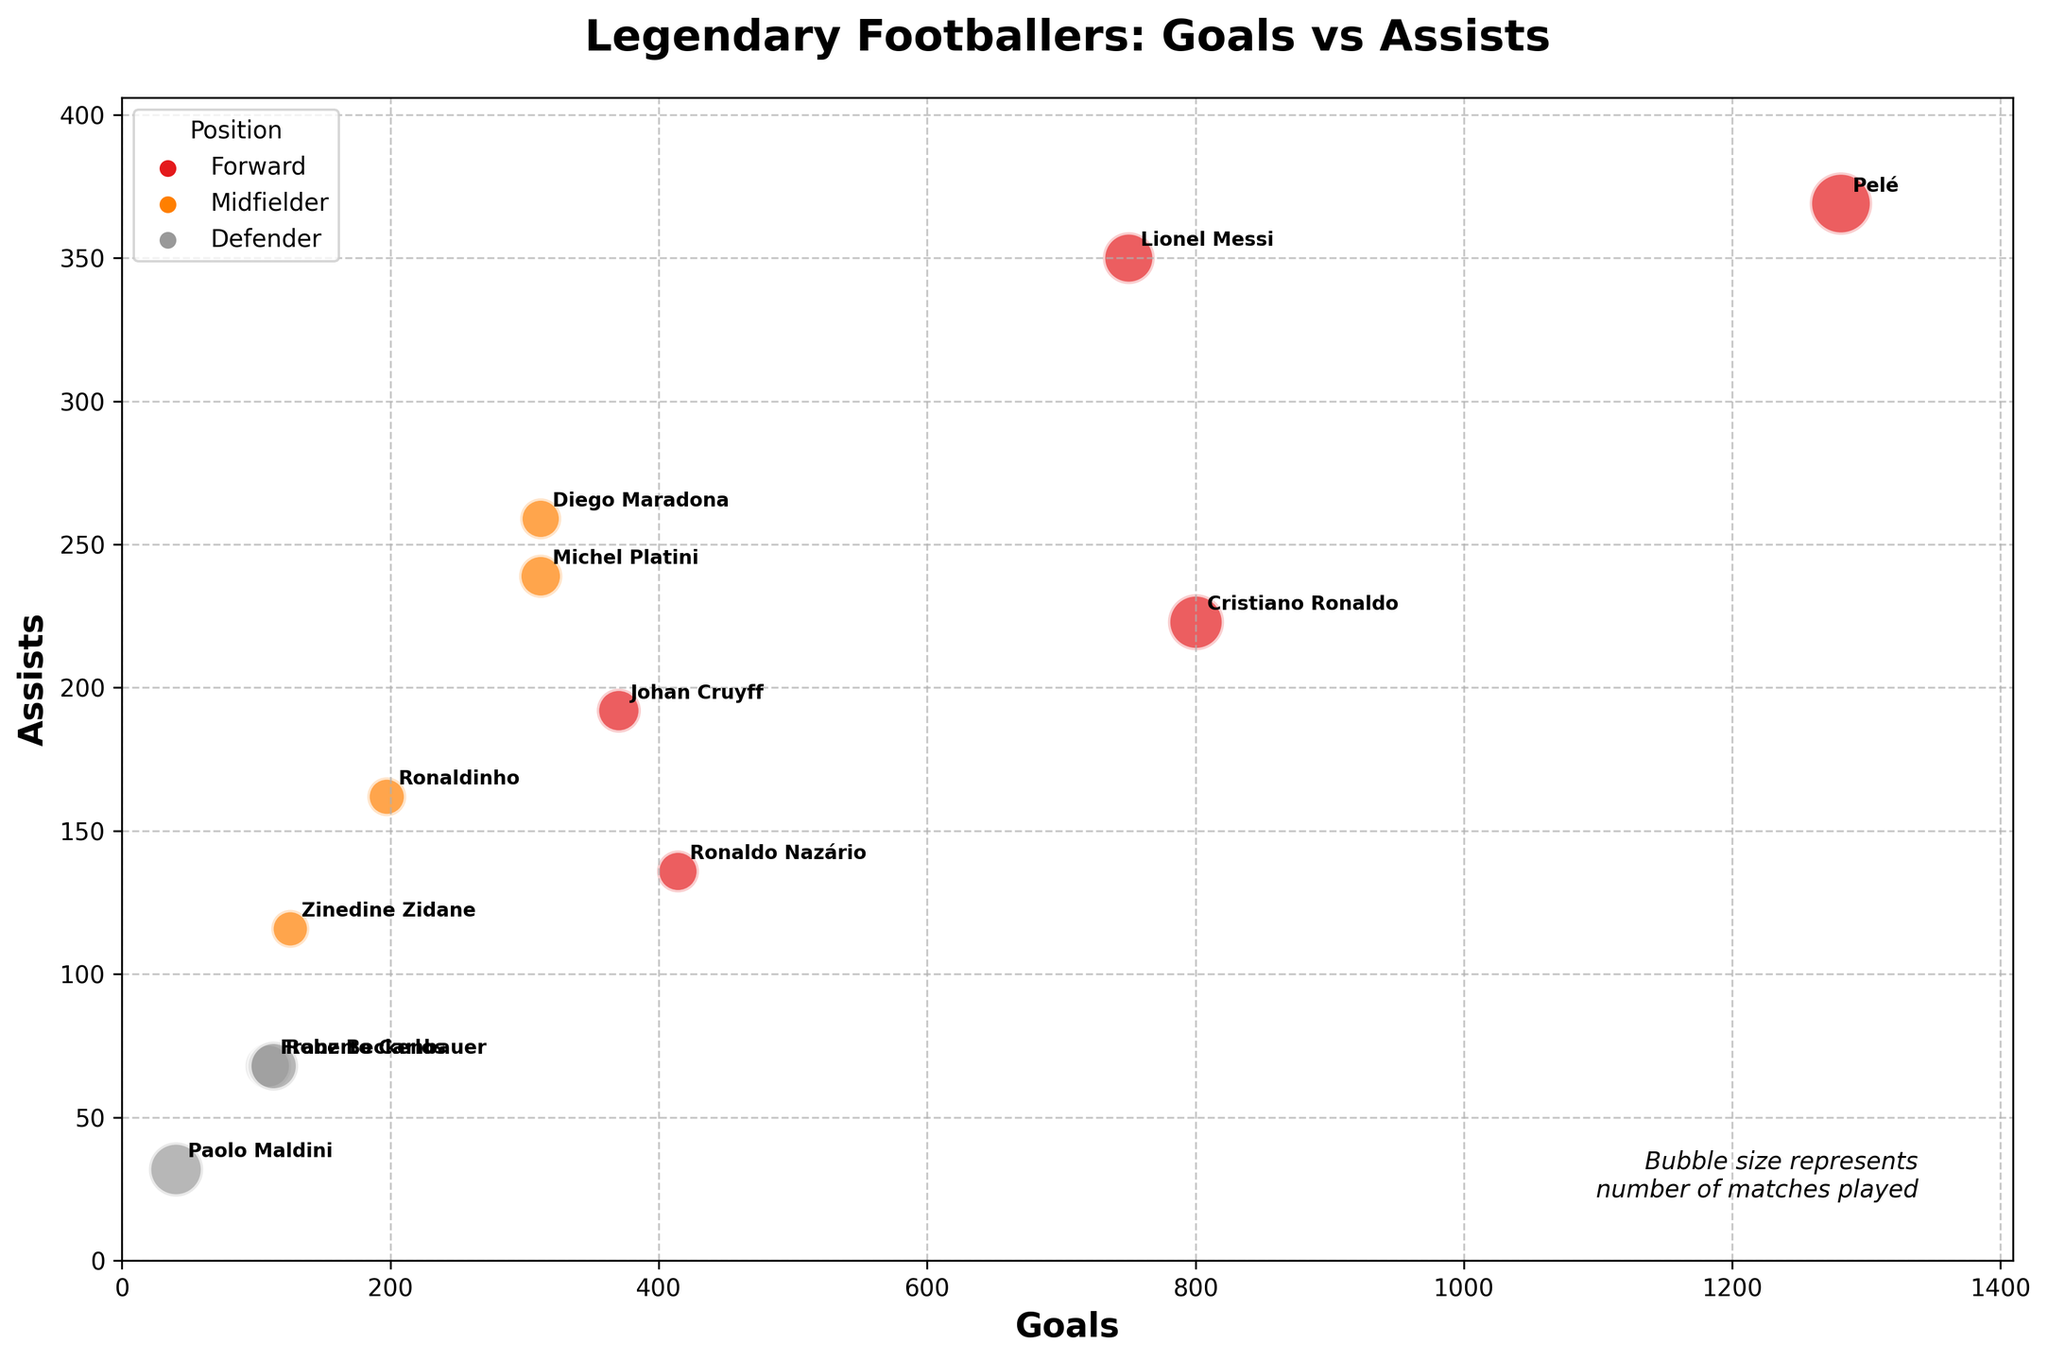what is the title of the plot? The title is written at the top of the plot and it clearly summarizes the main topic being visualized.
Answer: Legendary Footballers: Goals vs Assists how many positions are represented in the plot? The legend on the upper left of the plot lists all the unique positions that are color-coded in the bubble chart.
Answer: 4 who scored more goals, Pelé or Lionel Messi? Compare the position of Pelé’s and Lionel Messi's bubbles along the x-axis, which represents the number of goals.
Answer: Pelé which player has the largest bubble and what does it represent? The largest bubble is identified by its size, and according to the plot, bubble size represents the number of matches played.
Answer: Paolo Maldini, number of matches played what is the approximate number of assists by Cristiano Ronaldo? Cristiano Ronaldo can be identified by the label near his bubble, and the y-axis shows the number of assists.
Answer: 223 among the midfielders, who has the highest number of assists? To find this, look at the bubbles color-coded for midfielders and compare their position along the y-axis which represents assists.
Answer: Lionel Messi which defender scored the highest number of goals? Compare the positions of the bubbles color-coded for defenders along the x-axis, which represents goals.
Answer: Franz Beckenbauer are there more midfielders or forwards in the plot? Count the number of bubbles for each position as indicated by their respective colors in the legend.
Answer: Forwards which player from the 2000s-present era scored more goals? Cristiano Ronaldo or Lionel Messi? Compare the position of Cristiano Ronaldo’s and Lionel Messi's bubbles along the x-axis, which represents the number of goals.
Answer: Cristiano Ronaldo who has played the fewest matches among the listed players? Check the size of each bubble; the smallest size indicates the fewest matches.
Answer: Zinedine Zidane 